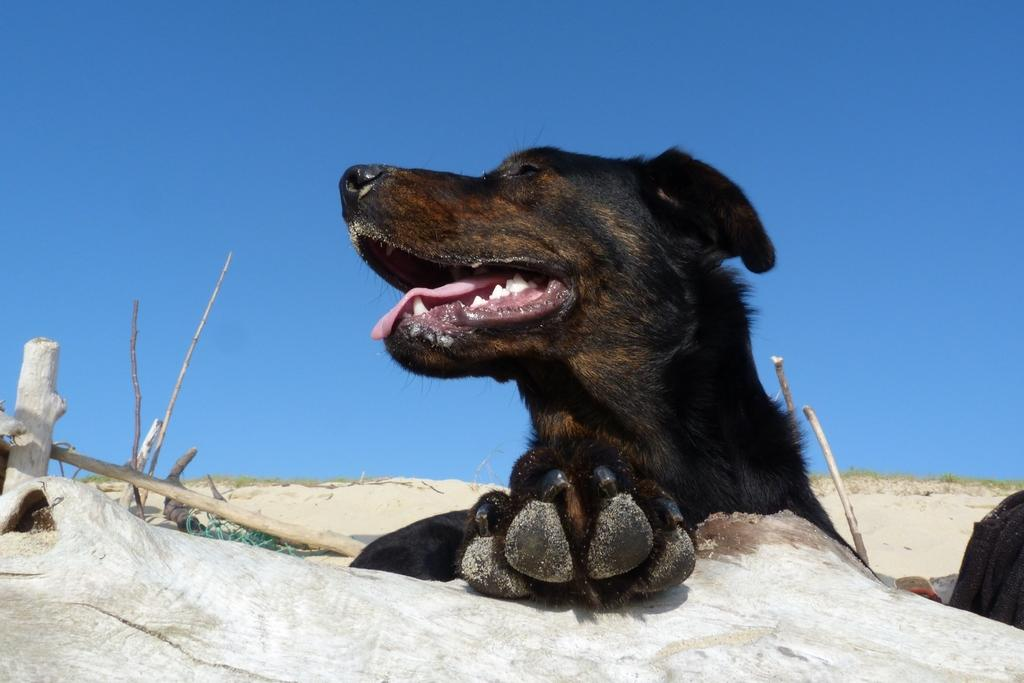What type of animal is in the image? There is an animal in the image, but its specific type cannot be determined from the provided facts. What is the animal standing near in the image? There is a tree trunk in the image, and the animal is standing near it. What other objects are in the image besides the animal and tree trunk? There are sticks and grass in the image. What can be seen in the background of the image? The sky is visible in the image. What type of pear is hanging from the tree trunk in the image? There is no pear present in the image; only an animal, tree trunk, sticks, grass, and the sky are visible. How many deer are visible in the image? There is no deer present in the image; only an animal, tree trunk, sticks, grass, and the sky are visible. 